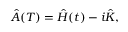<formula> <loc_0><loc_0><loc_500><loc_500>\begin{array} { r } { \hat { A } ( T ) = \hat { H } ( t ) - i \hat { K } , } \end{array}</formula> 